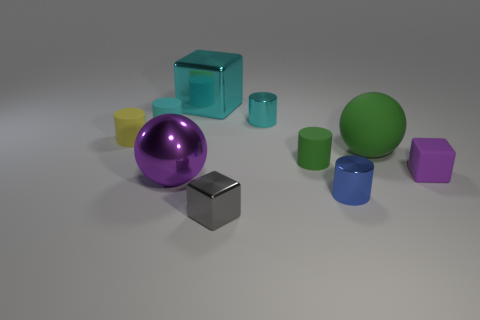Do the blue cylinder and the green object on the right side of the small blue thing have the same size?
Your response must be concise. No. What number of purple objects are tiny matte objects or metal cubes?
Your answer should be compact. 1. How many small cubes are there?
Offer a terse response. 2. How big is the metal cylinder in front of the tiny yellow rubber cylinder?
Offer a terse response. Small. Is the purple shiny sphere the same size as the cyan metal block?
Offer a very short reply. Yes. What number of things are either matte blocks or things that are left of the small gray shiny object?
Offer a very short reply. 5. What is the material of the tiny green thing?
Provide a succinct answer. Rubber. Is there any other thing that is the same color as the metallic ball?
Your response must be concise. Yes. Do the small yellow object and the large rubber object have the same shape?
Offer a terse response. No. What size is the cylinder in front of the green thing on the left side of the tiny blue shiny thing in front of the small green matte thing?
Keep it short and to the point. Small. 